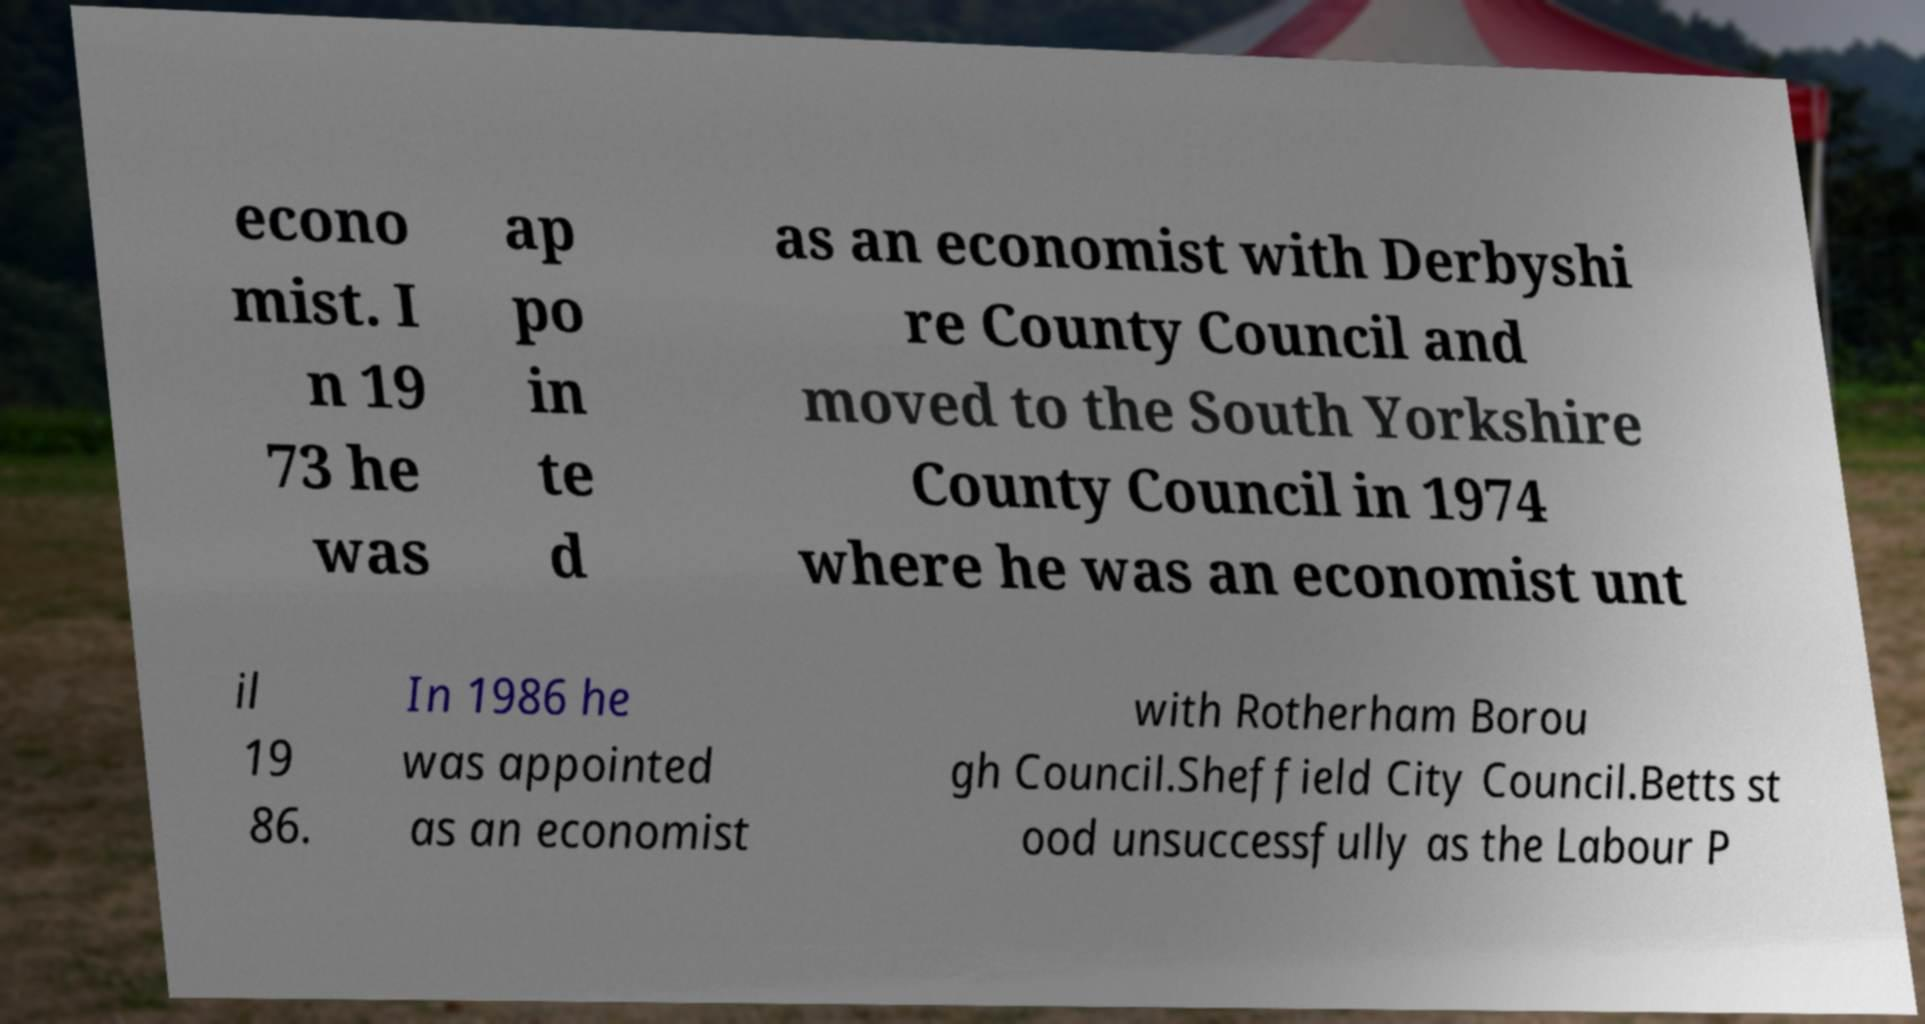Could you extract and type out the text from this image? econo mist. I n 19 73 he was ap po in te d as an economist with Derbyshi re County Council and moved to the South Yorkshire County Council in 1974 where he was an economist unt il 19 86. In 1986 he was appointed as an economist with Rotherham Borou gh Council.Sheffield City Council.Betts st ood unsuccessfully as the Labour P 